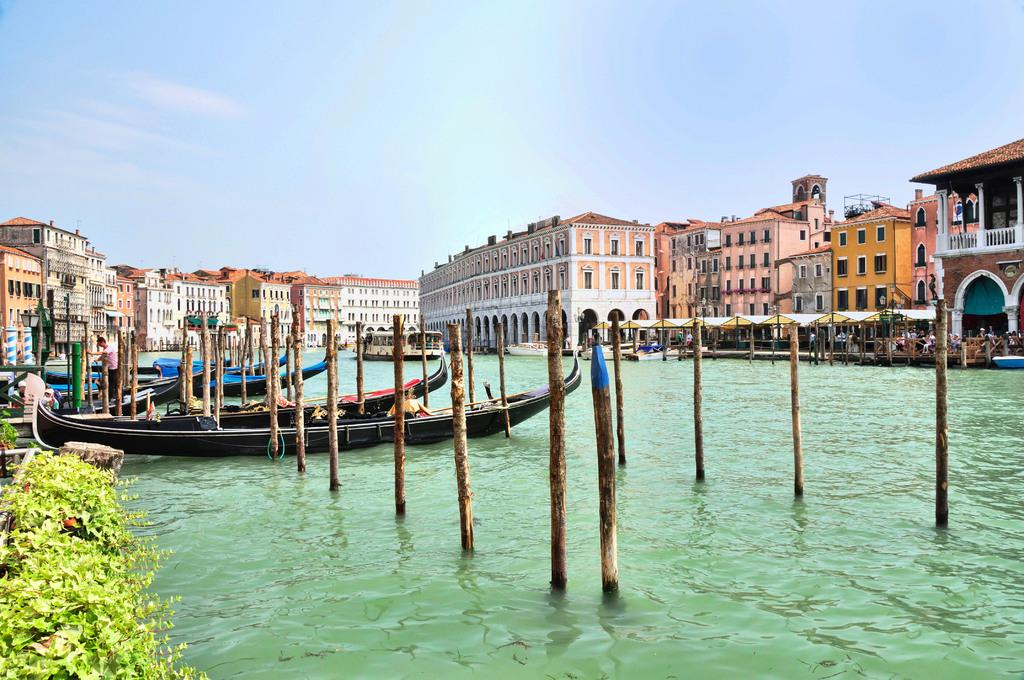What is floating on the water in the image? There are boats on the surface of the water in the image. What objects can be seen besides the boats? Wooden sticks and plants are visible in the image. What type of structures can be seen in the image? There are buildings in the image. What is visible at the top of the image? The sky is visible at the top of the image. What type of rice is being served with a spoon in the image? There is no rice or spoon present in the image; it features boats on the water, wooden sticks, plants, buildings, and the sky. 